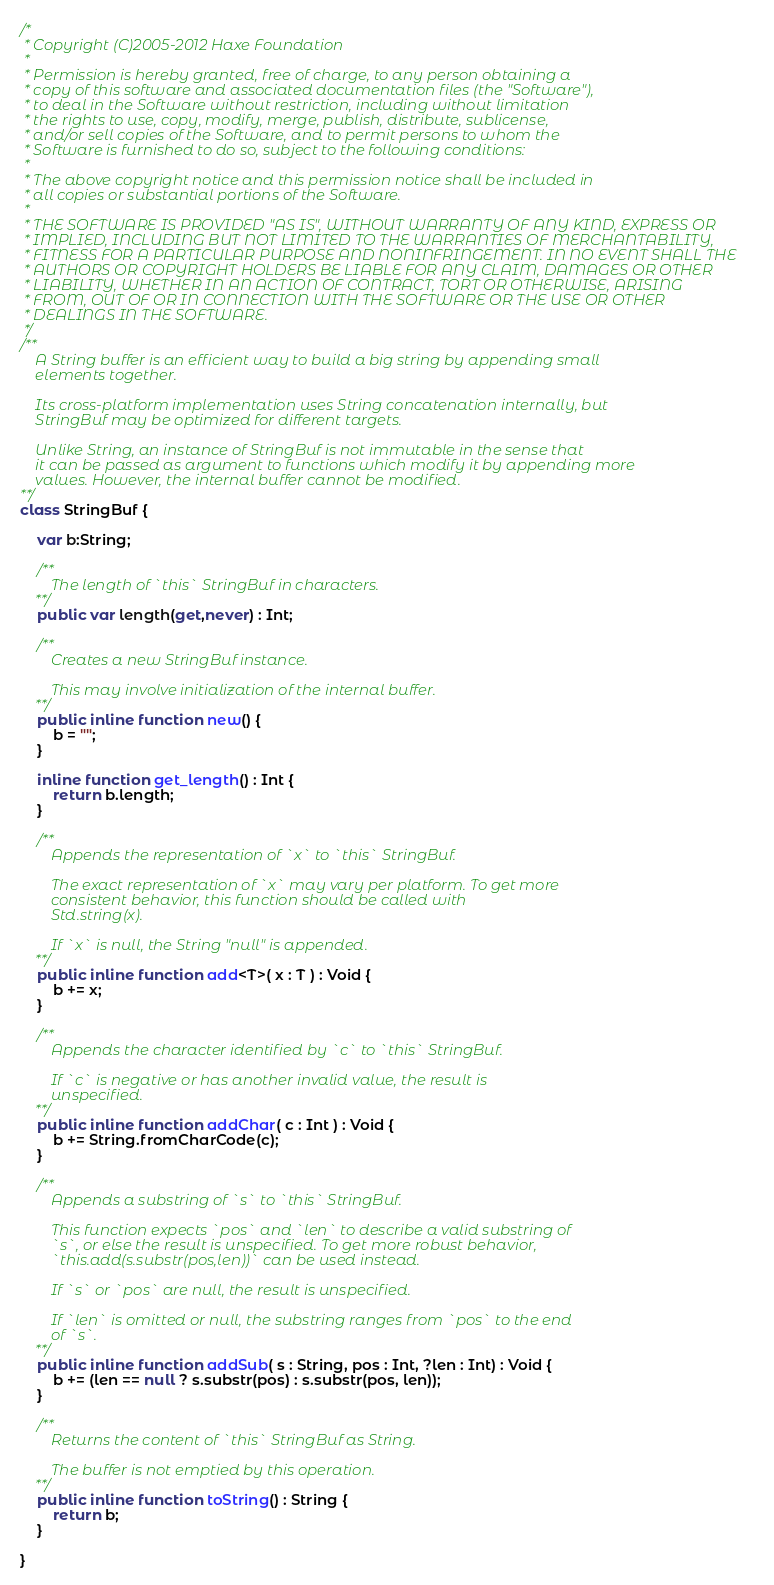<code> <loc_0><loc_0><loc_500><loc_500><_Haxe_>/*
 * Copyright (C)2005-2012 Haxe Foundation
 *
 * Permission is hereby granted, free of charge, to any person obtaining a
 * copy of this software and associated documentation files (the "Software"),
 * to deal in the Software without restriction, including without limitation
 * the rights to use, copy, modify, merge, publish, distribute, sublicense,
 * and/or sell copies of the Software, and to permit persons to whom the
 * Software is furnished to do so, subject to the following conditions:
 *
 * The above copyright notice and this permission notice shall be included in
 * all copies or substantial portions of the Software.
 *
 * THE SOFTWARE IS PROVIDED "AS IS", WITHOUT WARRANTY OF ANY KIND, EXPRESS OR
 * IMPLIED, INCLUDING BUT NOT LIMITED TO THE WARRANTIES OF MERCHANTABILITY,
 * FITNESS FOR A PARTICULAR PURPOSE AND NONINFRINGEMENT. IN NO EVENT SHALL THE
 * AUTHORS OR COPYRIGHT HOLDERS BE LIABLE FOR ANY CLAIM, DAMAGES OR OTHER
 * LIABILITY, WHETHER IN AN ACTION OF CONTRACT, TORT OR OTHERWISE, ARISING
 * FROM, OUT OF OR IN CONNECTION WITH THE SOFTWARE OR THE USE OR OTHER
 * DEALINGS IN THE SOFTWARE.
 */
/**
	A String buffer is an efficient way to build a big string by appending small
	elements together.

	Its cross-platform implementation uses String concatenation internally, but
	StringBuf may be optimized for different targets.

	Unlike String, an instance of StringBuf is not immutable in the sense that
	it can be passed as argument to functions which modify it by appending more
	values. However, the internal buffer cannot be modified.
**/
class StringBuf {

	var b:String;

	/**
		The length of `this` StringBuf in characters.
	**/
	public var length(get,never) : Int;

	/**
		Creates a new StringBuf instance.

		This may involve initialization of the internal buffer.
	**/
	public inline function new() {
		b = "";
	}

	inline function get_length() : Int {
		return b.length;
	}

	/**
		Appends the representation of `x` to `this` StringBuf.

		The exact representation of `x` may vary per platform. To get more
		consistent behavior, this function should be called with
		Std.string(x).

		If `x` is null, the String "null" is appended.
	**/
	public inline function add<T>( x : T ) : Void {
		b += x;
	}

	/**
		Appends the character identified by `c` to `this` StringBuf.

		If `c` is negative or has another invalid value, the result is
		unspecified.
	**/
	public inline function addChar( c : Int ) : Void {
		b += String.fromCharCode(c);
	}

	/**
		Appends a substring of `s` to `this` StringBuf.

		This function expects `pos` and `len` to describe a valid substring of
		`s`, or else the result is unspecified. To get more robust behavior,
		`this.add(s.substr(pos,len))` can be used instead.

		If `s` or `pos` are null, the result is unspecified.

		If `len` is omitted or null, the substring ranges from `pos` to the end
		of `s`.
	**/
	public inline function addSub( s : String, pos : Int, ?len : Int) : Void {
		b += (len == null ? s.substr(pos) : s.substr(pos, len));
	}

	/**
		Returns the content of `this` StringBuf as String.

		The buffer is not emptied by this operation.
	**/
	public inline function toString() : String {
		return b;
	}

}
</code> 